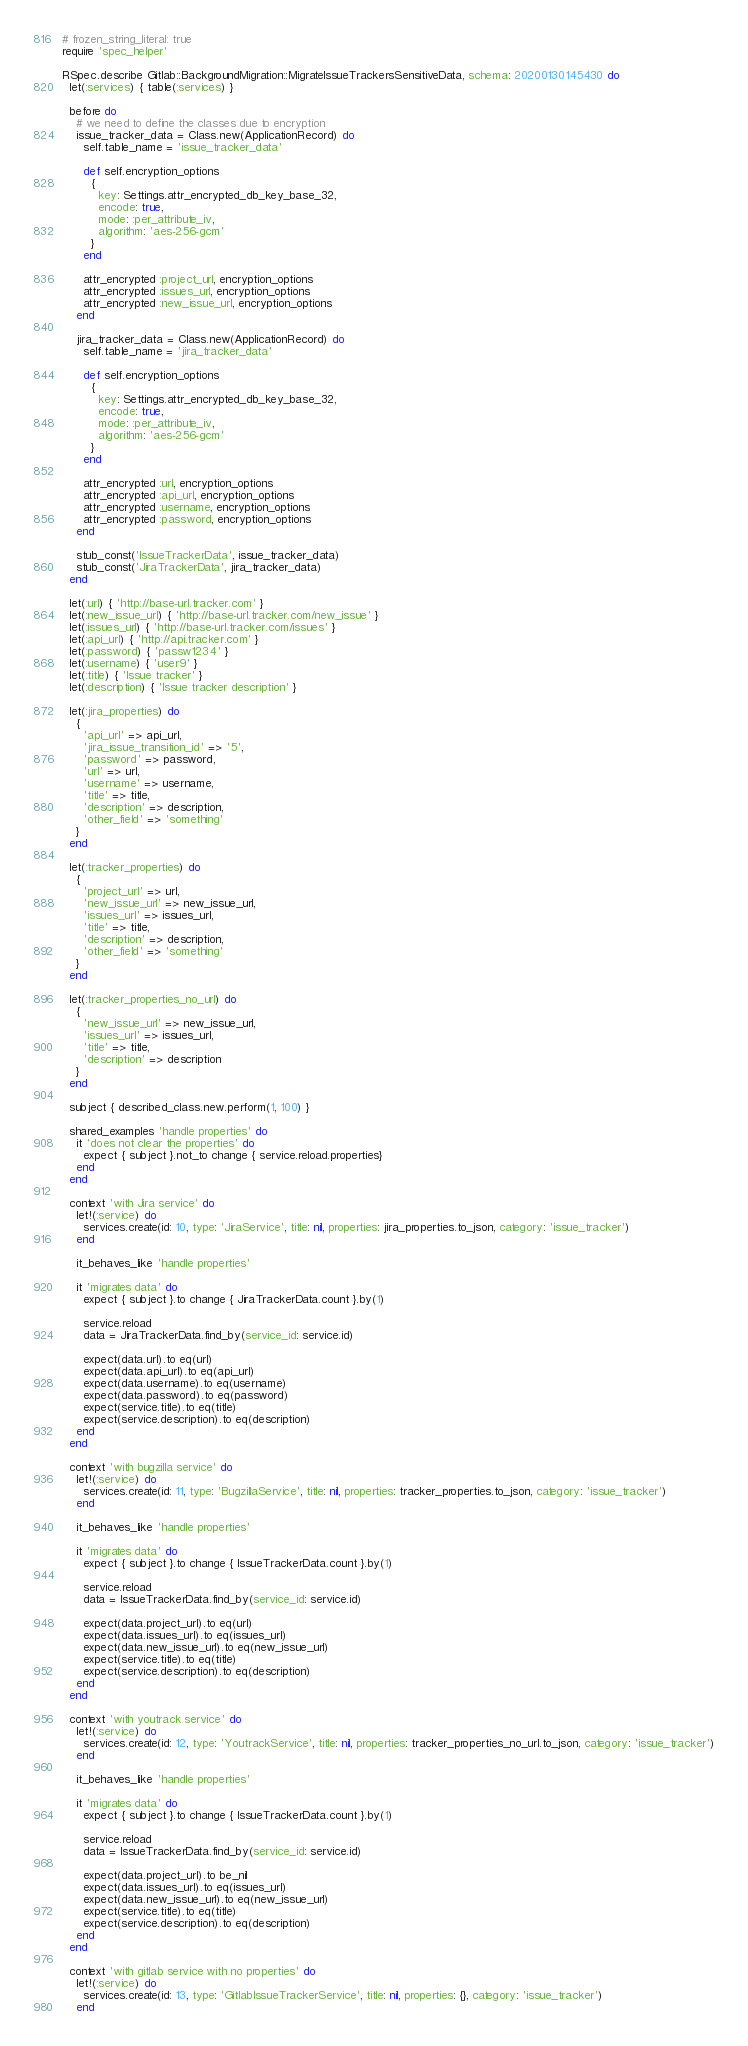<code> <loc_0><loc_0><loc_500><loc_500><_Ruby_># frozen_string_literal: true
require 'spec_helper'

RSpec.describe Gitlab::BackgroundMigration::MigrateIssueTrackersSensitiveData, schema: 20200130145430 do
  let(:services) { table(:services) }

  before do
    # we need to define the classes due to encryption
    issue_tracker_data = Class.new(ApplicationRecord) do
      self.table_name = 'issue_tracker_data'

      def self.encryption_options
        {
          key: Settings.attr_encrypted_db_key_base_32,
          encode: true,
          mode: :per_attribute_iv,
          algorithm: 'aes-256-gcm'
        }
      end

      attr_encrypted :project_url, encryption_options
      attr_encrypted :issues_url, encryption_options
      attr_encrypted :new_issue_url, encryption_options
    end

    jira_tracker_data = Class.new(ApplicationRecord) do
      self.table_name = 'jira_tracker_data'

      def self.encryption_options
        {
          key: Settings.attr_encrypted_db_key_base_32,
          encode: true,
          mode: :per_attribute_iv,
          algorithm: 'aes-256-gcm'
        }
      end

      attr_encrypted :url, encryption_options
      attr_encrypted :api_url, encryption_options
      attr_encrypted :username, encryption_options
      attr_encrypted :password, encryption_options
    end

    stub_const('IssueTrackerData', issue_tracker_data)
    stub_const('JiraTrackerData', jira_tracker_data)
  end

  let(:url) { 'http://base-url.tracker.com' }
  let(:new_issue_url) { 'http://base-url.tracker.com/new_issue' }
  let(:issues_url) { 'http://base-url.tracker.com/issues' }
  let(:api_url) { 'http://api.tracker.com' }
  let(:password) { 'passw1234' }
  let(:username) { 'user9' }
  let(:title) { 'Issue tracker' }
  let(:description) { 'Issue tracker description' }

  let(:jira_properties) do
    {
      'api_url' => api_url,
      'jira_issue_transition_id' => '5',
      'password' => password,
      'url' => url,
      'username' => username,
      'title' => title,
      'description' => description,
      'other_field' => 'something'
    }
  end

  let(:tracker_properties) do
    {
      'project_url' => url,
      'new_issue_url' => new_issue_url,
      'issues_url' => issues_url,
      'title' => title,
      'description' => description,
      'other_field' => 'something'
    }
  end

  let(:tracker_properties_no_url) do
    {
      'new_issue_url' => new_issue_url,
      'issues_url' => issues_url,
      'title' => title,
      'description' => description
    }
  end

  subject { described_class.new.perform(1, 100) }

  shared_examples 'handle properties' do
    it 'does not clear the properties' do
      expect { subject }.not_to change { service.reload.properties}
    end
  end

  context 'with Jira service' do
    let!(:service) do
      services.create(id: 10, type: 'JiraService', title: nil, properties: jira_properties.to_json, category: 'issue_tracker')
    end

    it_behaves_like 'handle properties'

    it 'migrates data' do
      expect { subject }.to change { JiraTrackerData.count }.by(1)

      service.reload
      data = JiraTrackerData.find_by(service_id: service.id)

      expect(data.url).to eq(url)
      expect(data.api_url).to eq(api_url)
      expect(data.username).to eq(username)
      expect(data.password).to eq(password)
      expect(service.title).to eq(title)
      expect(service.description).to eq(description)
    end
  end

  context 'with bugzilla service' do
    let!(:service) do
      services.create(id: 11, type: 'BugzillaService', title: nil, properties: tracker_properties.to_json, category: 'issue_tracker')
    end

    it_behaves_like 'handle properties'

    it 'migrates data' do
      expect { subject }.to change { IssueTrackerData.count }.by(1)

      service.reload
      data = IssueTrackerData.find_by(service_id: service.id)

      expect(data.project_url).to eq(url)
      expect(data.issues_url).to eq(issues_url)
      expect(data.new_issue_url).to eq(new_issue_url)
      expect(service.title).to eq(title)
      expect(service.description).to eq(description)
    end
  end

  context 'with youtrack service' do
    let!(:service) do
      services.create(id: 12, type: 'YoutrackService', title: nil, properties: tracker_properties_no_url.to_json, category: 'issue_tracker')
    end

    it_behaves_like 'handle properties'

    it 'migrates data' do
      expect { subject }.to change { IssueTrackerData.count }.by(1)

      service.reload
      data = IssueTrackerData.find_by(service_id: service.id)

      expect(data.project_url).to be_nil
      expect(data.issues_url).to eq(issues_url)
      expect(data.new_issue_url).to eq(new_issue_url)
      expect(service.title).to eq(title)
      expect(service.description).to eq(description)
    end
  end

  context 'with gitlab service with no properties' do
    let!(:service) do
      services.create(id: 13, type: 'GitlabIssueTrackerService', title: nil, properties: {}, category: 'issue_tracker')
    end
</code> 